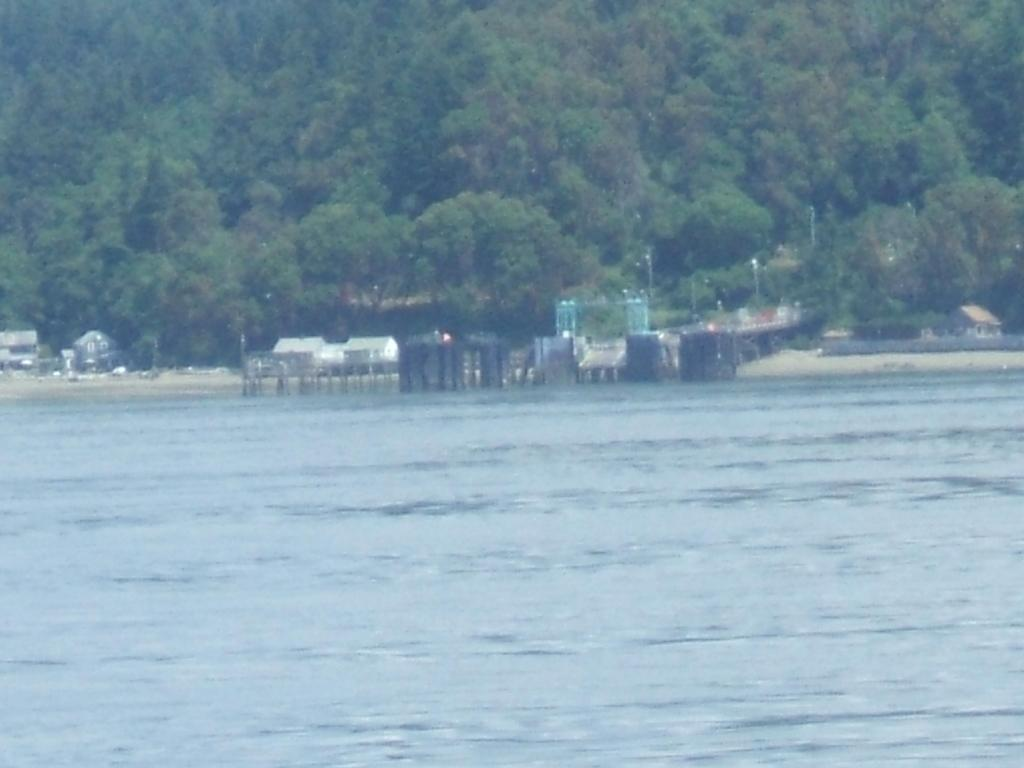What type of structures can be seen in the image? There are houses in the image. What natural elements are present in the image? There are trees in the image. What man-made objects can be seen in the image? There are poles in the image. What is the platform near in the image? The platform is near a river in the image. What does the handwritten caption on the image say? There is no handwritten caption present in the image. Can you describe the girl in the image? There is no girl present in the image. 